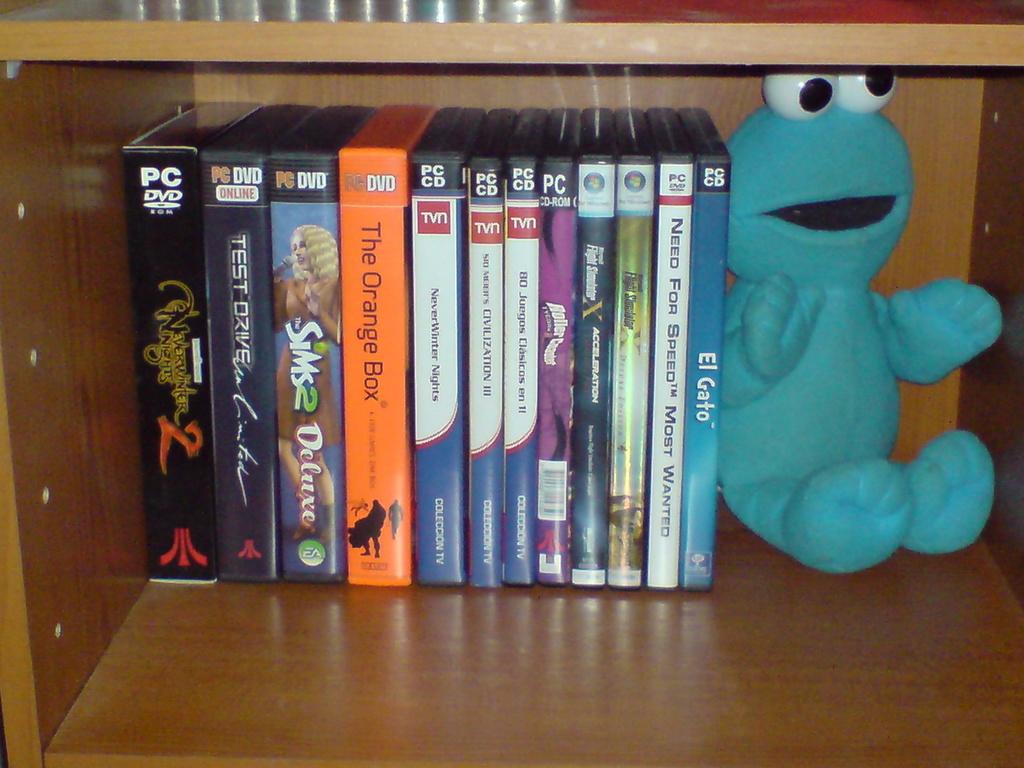What is the title on the orange box?
Offer a terse response. The orange box. Do they have a need for speed game?
Your response must be concise. Yes. 